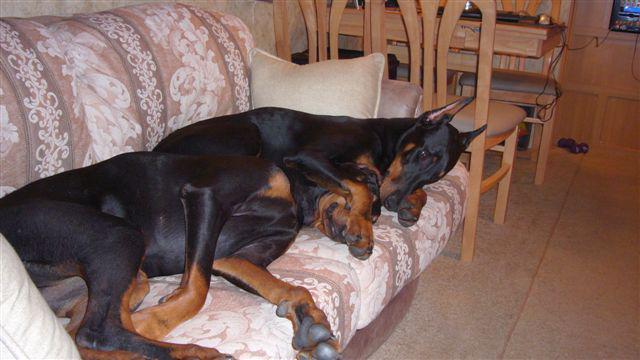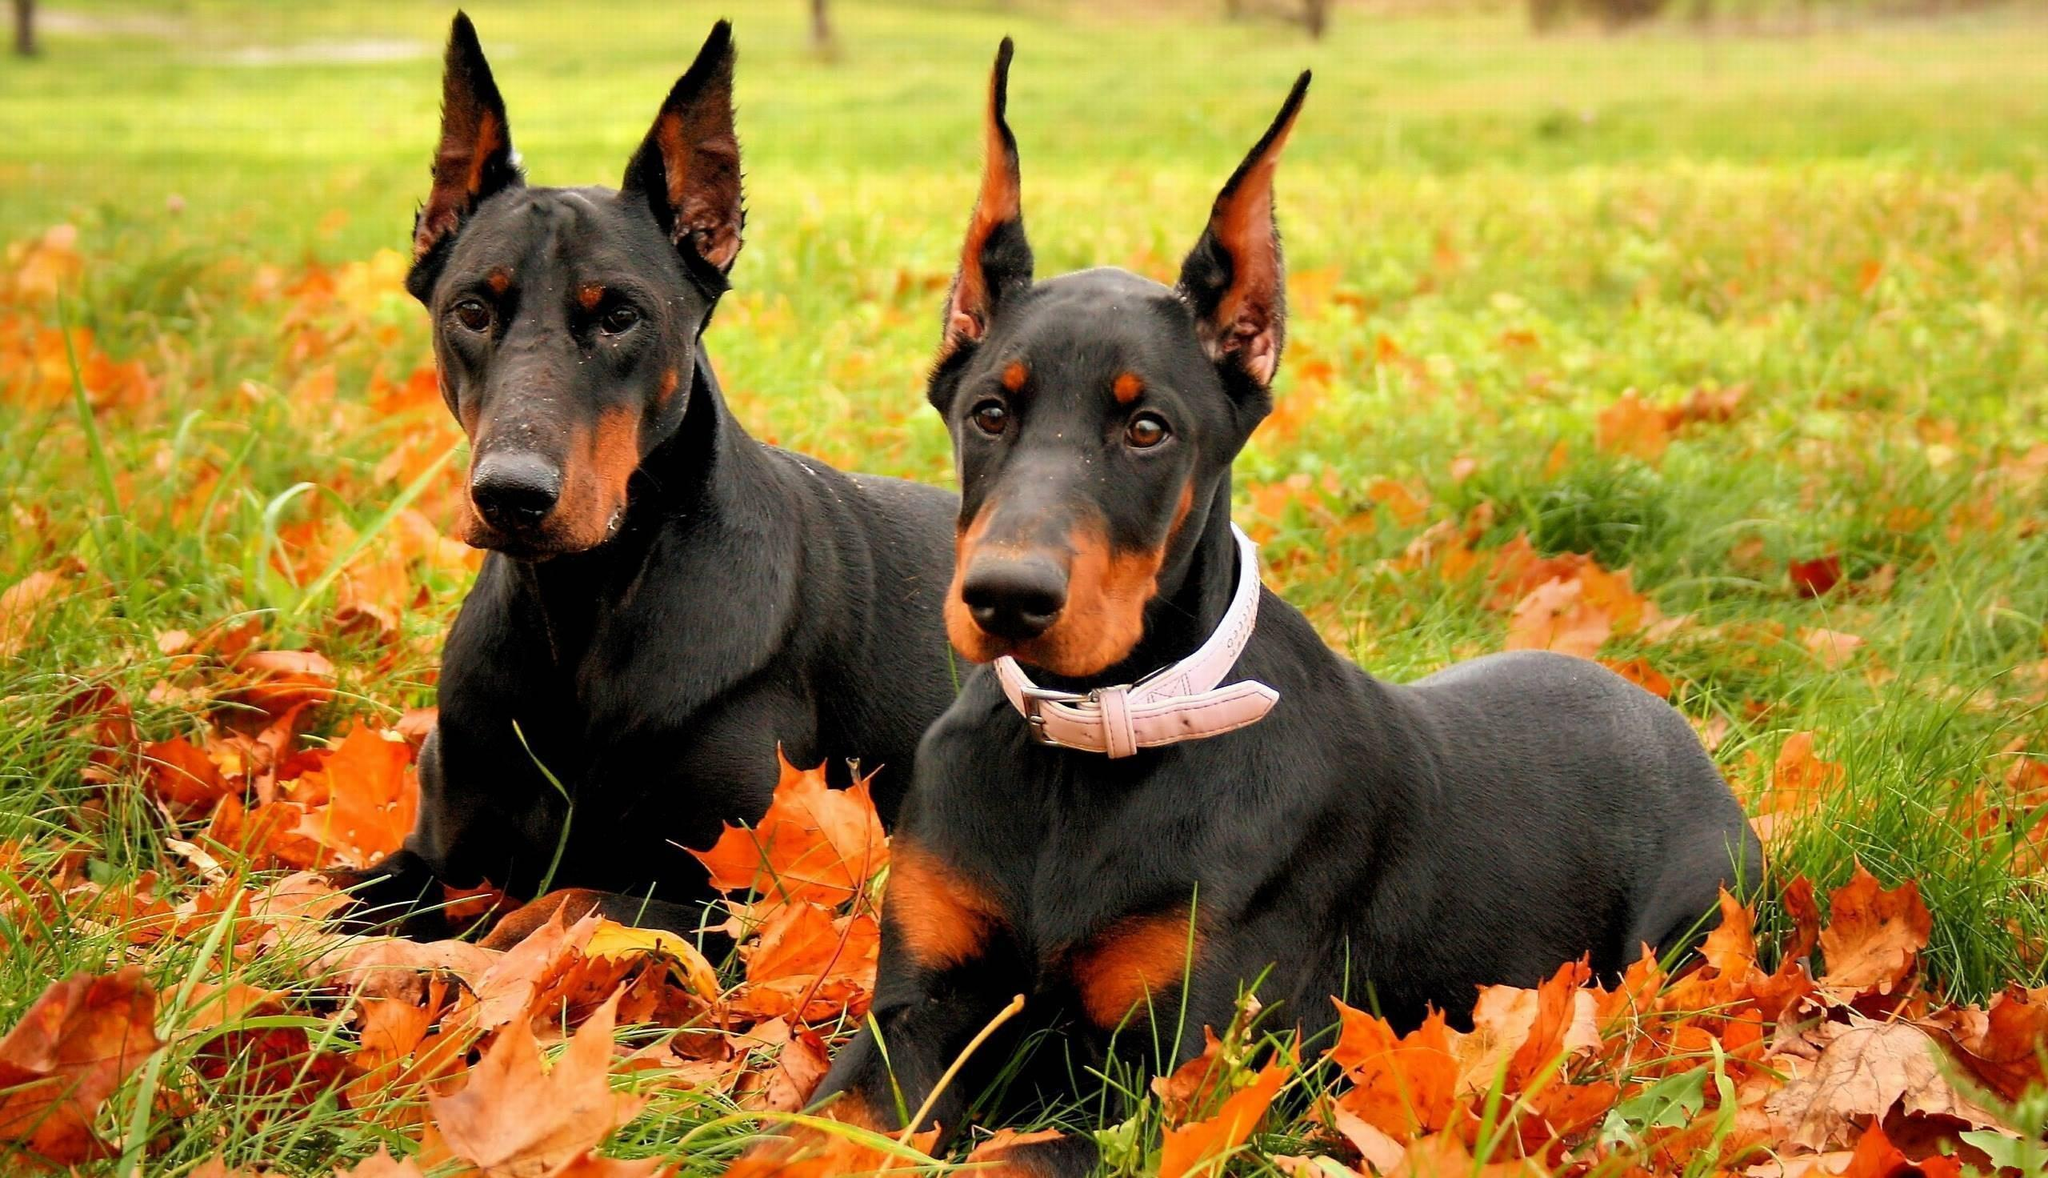The first image is the image on the left, the second image is the image on the right. Evaluate the accuracy of this statement regarding the images: "The left image contains exactly one dog.". Is it true? Answer yes or no. No. 